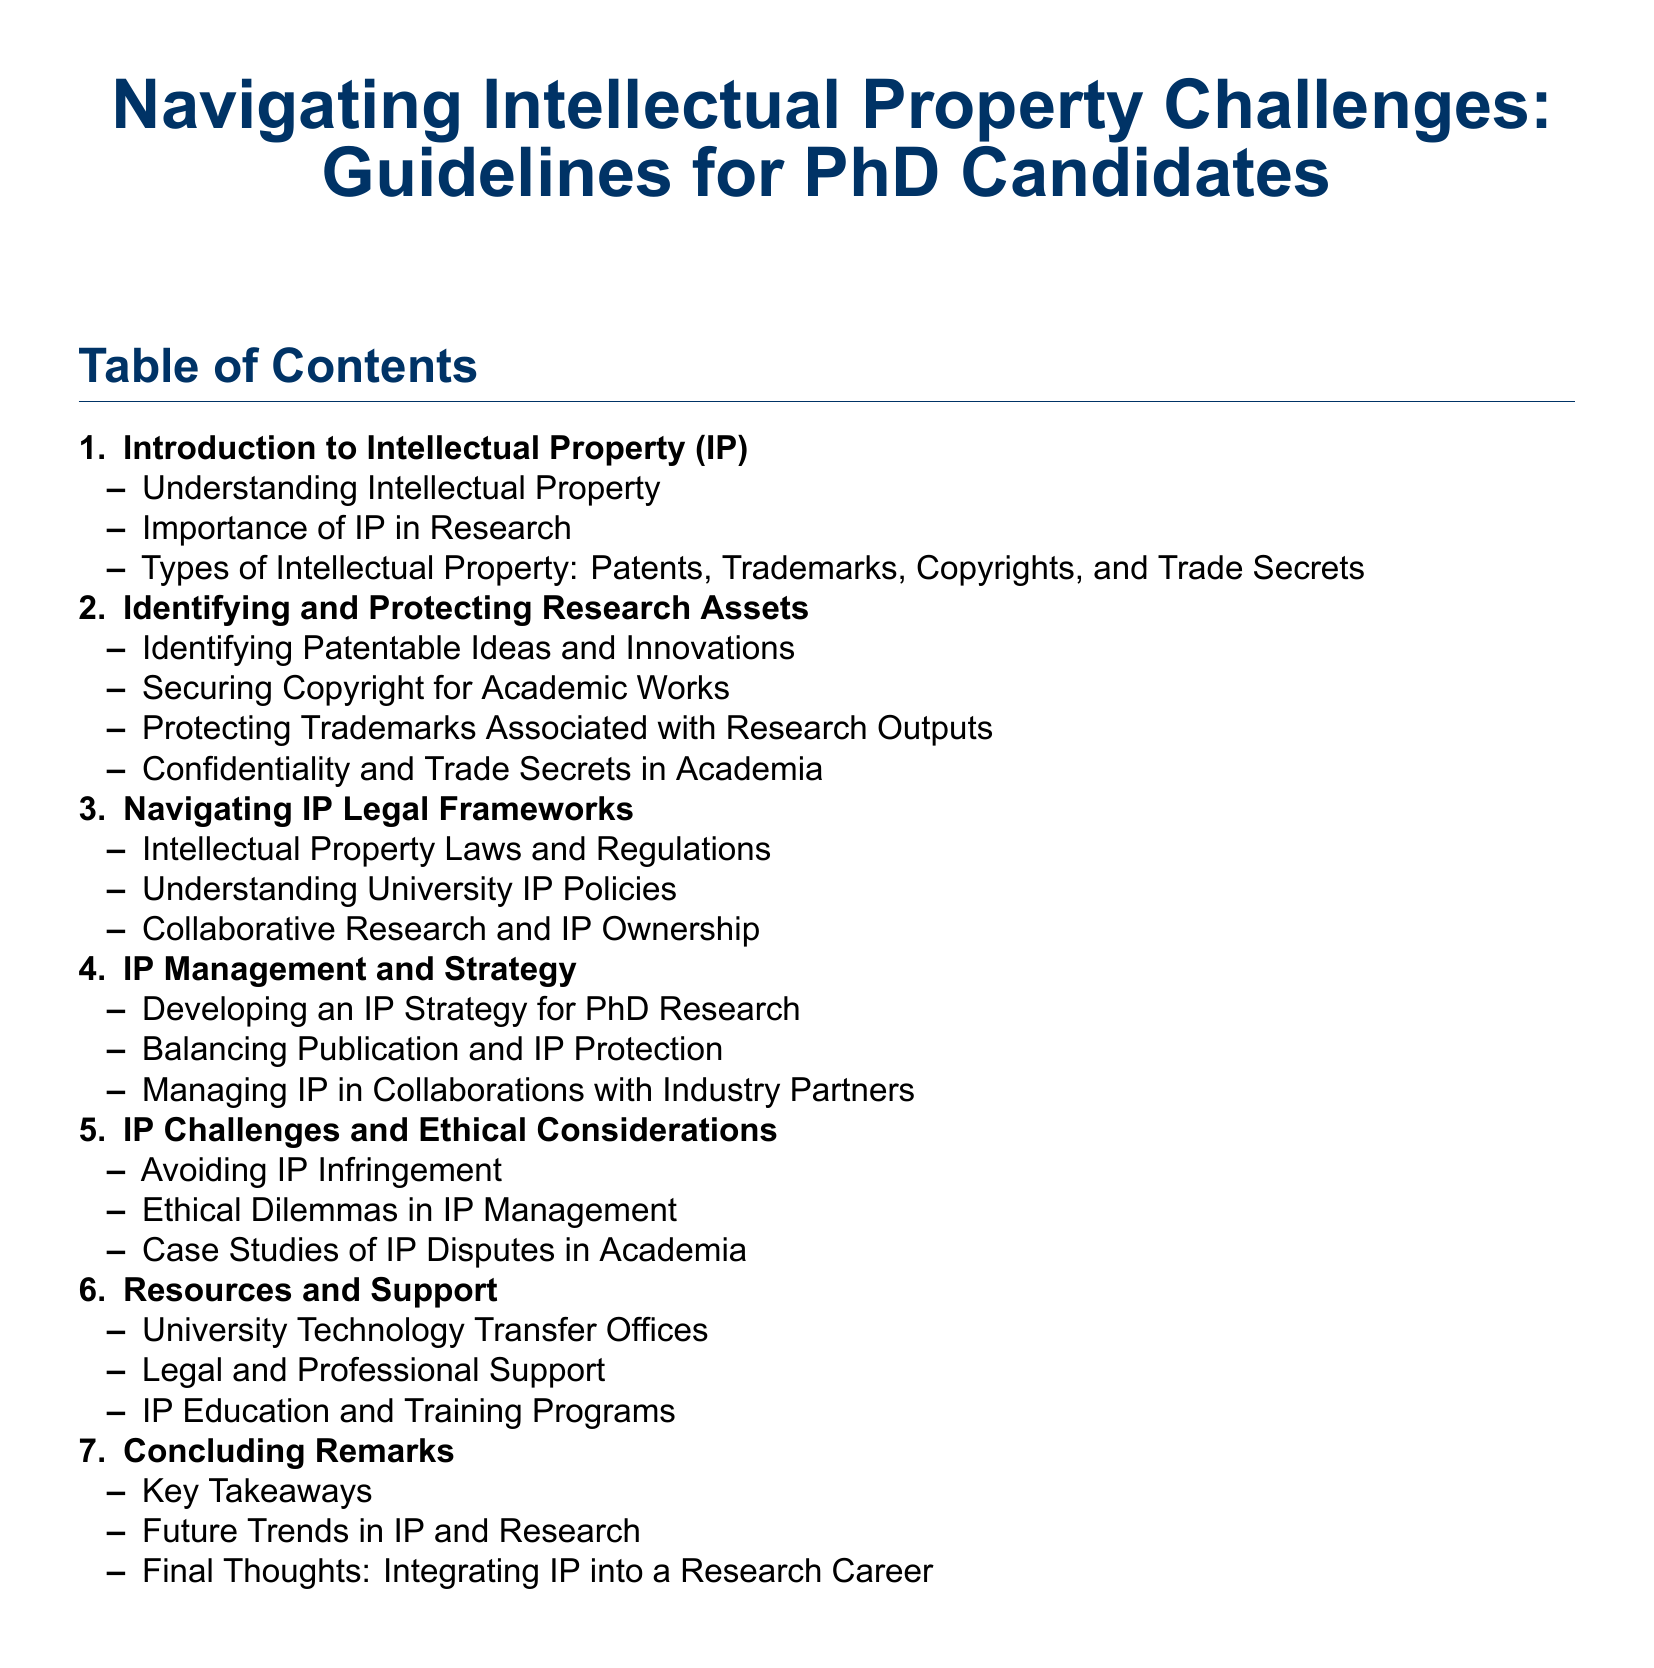What is the first section in the Table of Contents? The first section is labeled "1." and is titled "Introduction to Intellectual Property (IP)."
Answer: Introduction to Intellectual Property (IP) How many main sections are there in the document? The document contains seven main sections listed in the Table of Contents.
Answer: 7 What type of Intellectual Property is discussed in the first section? The first section outlines types of Intellectual Property which include Patents, Trademarks, Copyrights, and Trade Secrets.
Answer: Patents, Trademarks, Copyrights, and Trade Secrets What is one of the topics listed under the second section? The second section focuses on identifying and protecting research assets, which includes identifying patentable ideas and innovations.
Answer: Identifying Patentable Ideas and Innovations What is the focus of the fourth section? The fourth section is about IP management and developing strategies, with an emphasis on creating an IP strategy for PhD research.
Answer: IP Management and Strategy In which section would you find information about avoiding ethical dilemmas? Information about avoiding ethical dilemmas in IP management is covered in the fifth section titled "IP Challenges and Ethical Considerations."
Answer: IP Challenges and Ethical Considerations What is the last section titled? The last section is titled "Concluding Remarks."
Answer: Concluding Remarks 